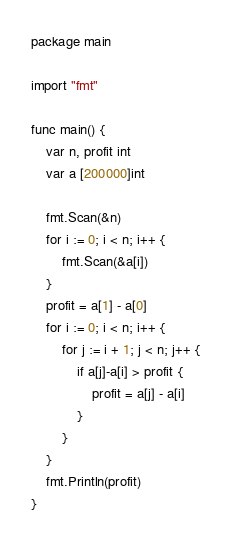Convert code to text. <code><loc_0><loc_0><loc_500><loc_500><_Go_>package main

import "fmt"

func main() {
	var n, profit int
	var a [200000]int

	fmt.Scan(&n)
	for i := 0; i < n; i++ {
		fmt.Scan(&a[i])
	}
	profit = a[1] - a[0]
	for i := 0; i < n; i++ {
		for j := i + 1; j < n; j++ {
			if a[j]-a[i] > profit {
				profit = a[j] - a[i]
			}
		}
	}
	fmt.Println(profit)
}

</code> 